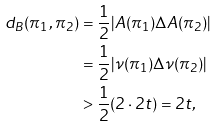Convert formula to latex. <formula><loc_0><loc_0><loc_500><loc_500>d _ { B } ( \pi _ { 1 } , \pi _ { 2 } ) & = \frac { 1 } { 2 } | A ( \pi _ { 1 } ) \Delta A ( \pi _ { 2 } ) | \\ & = \frac { 1 } { 2 } | \nu ( \pi _ { 1 } ) \Delta \nu ( \pi _ { 2 } ) | \\ & > \frac { 1 } { 2 } ( 2 \cdot 2 t ) = 2 t ,</formula> 